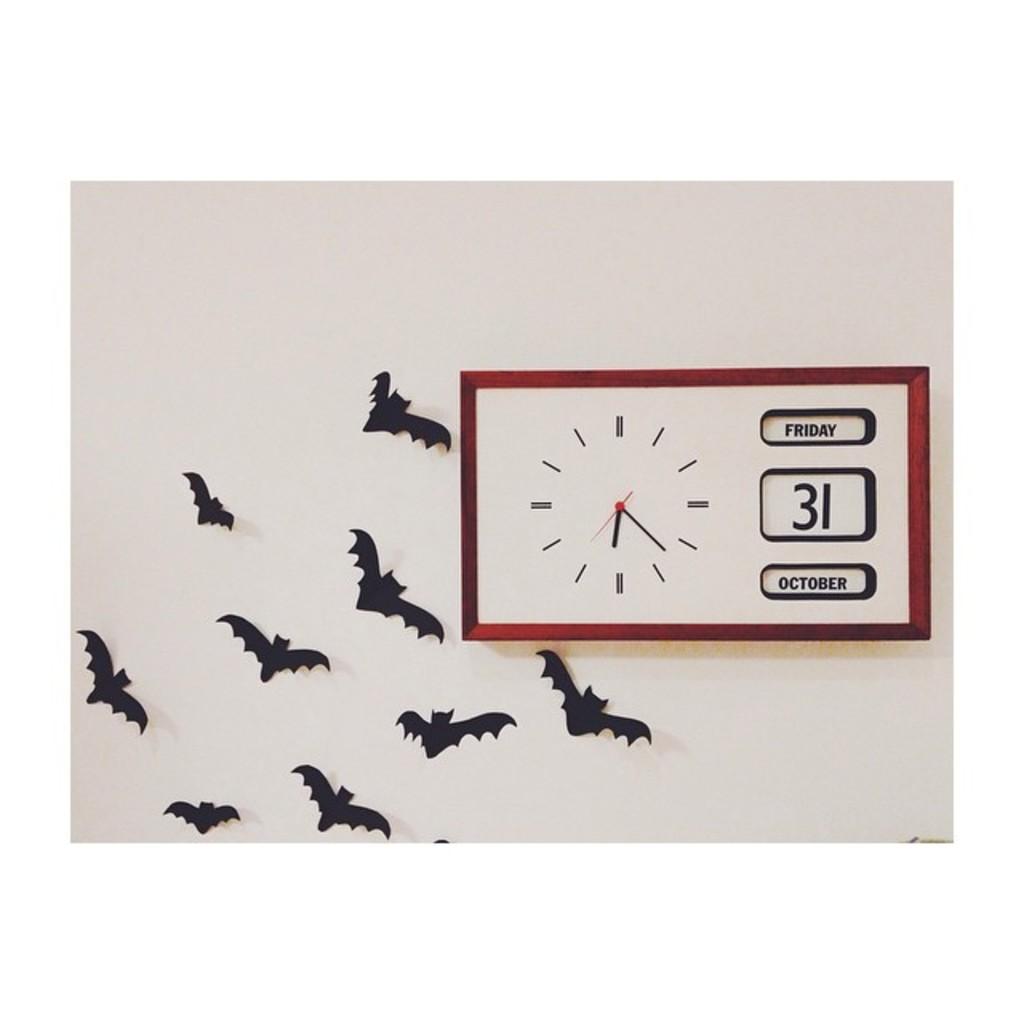What date is on the clock ?
Your answer should be compact. 31 october. What day of the week is this?
Give a very brief answer. Friday. 